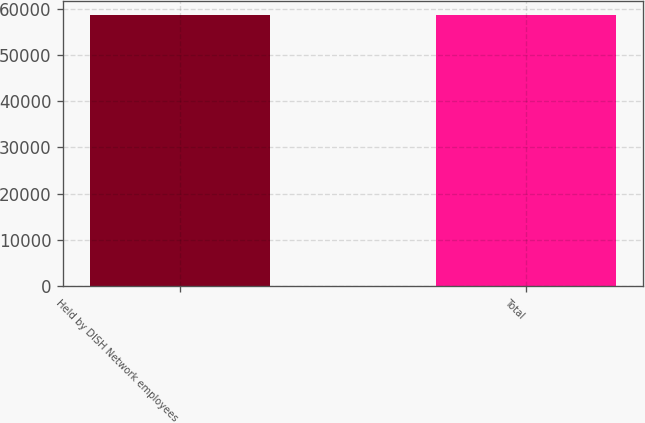<chart> <loc_0><loc_0><loc_500><loc_500><bar_chart><fcel>Held by DISH Network employees<fcel>Total<nl><fcel>58784<fcel>58784.1<nl></chart> 